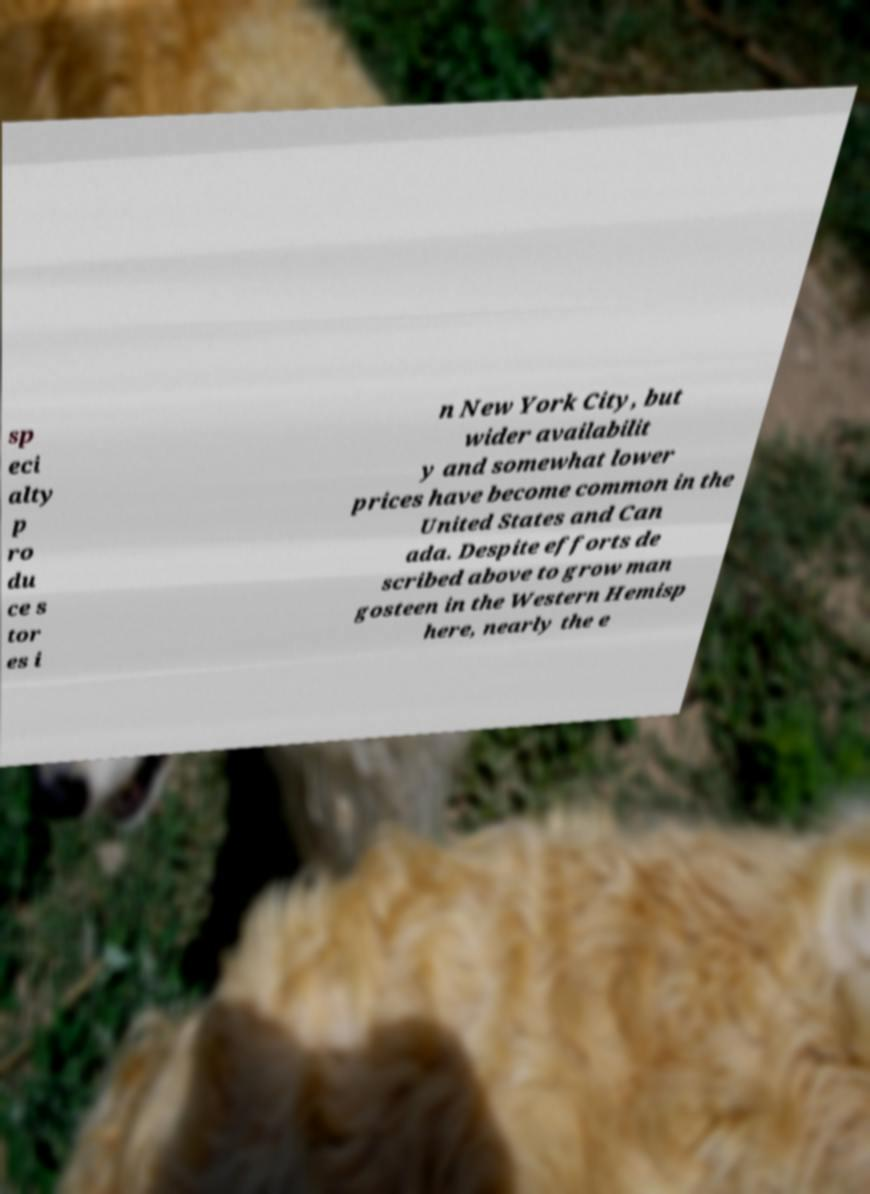Please read and relay the text visible in this image. What does it say? sp eci alty p ro du ce s tor es i n New York City, but wider availabilit y and somewhat lower prices have become common in the United States and Can ada. Despite efforts de scribed above to grow man gosteen in the Western Hemisp here, nearly the e 